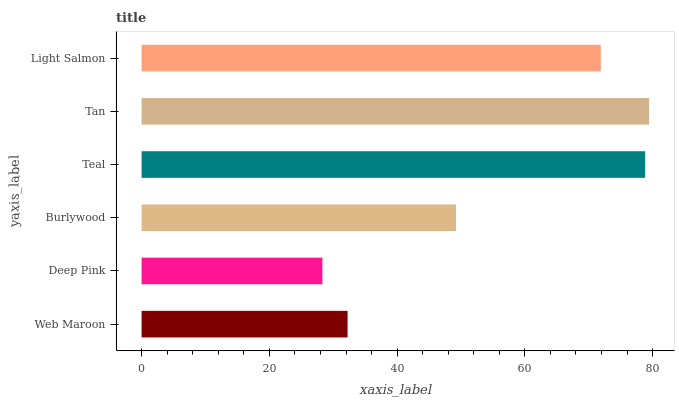Is Deep Pink the minimum?
Answer yes or no. Yes. Is Tan the maximum?
Answer yes or no. Yes. Is Burlywood the minimum?
Answer yes or no. No. Is Burlywood the maximum?
Answer yes or no. No. Is Burlywood greater than Deep Pink?
Answer yes or no. Yes. Is Deep Pink less than Burlywood?
Answer yes or no. Yes. Is Deep Pink greater than Burlywood?
Answer yes or no. No. Is Burlywood less than Deep Pink?
Answer yes or no. No. Is Light Salmon the high median?
Answer yes or no. Yes. Is Burlywood the low median?
Answer yes or no. Yes. Is Burlywood the high median?
Answer yes or no. No. Is Light Salmon the low median?
Answer yes or no. No. 